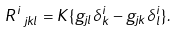<formula> <loc_0><loc_0><loc_500><loc_500>R ^ { i } _ { \ j k l } = { K } \{ g _ { j l } \delta ^ { i } _ { k } - g _ { j k } \delta ^ { i } _ { l } \} .</formula> 